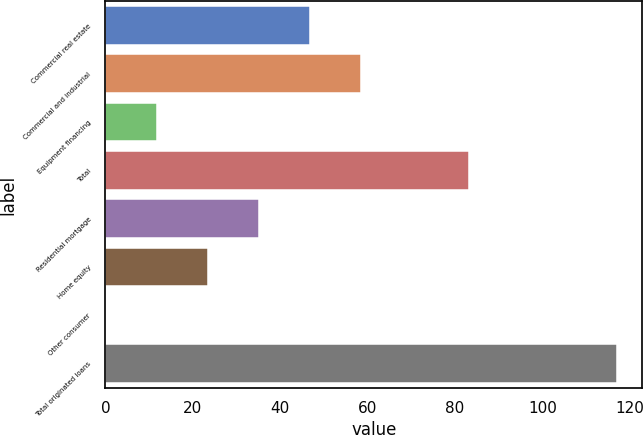Convert chart to OTSL. <chart><loc_0><loc_0><loc_500><loc_500><bar_chart><fcel>Commercial real estate<fcel>Commercial and industrial<fcel>Equipment financing<fcel>Total<fcel>Residential mortgage<fcel>Home equity<fcel>Other consumer<fcel>Total originated loans<nl><fcel>46.86<fcel>58.55<fcel>11.79<fcel>83.2<fcel>35.17<fcel>23.48<fcel>0.1<fcel>117<nl></chart> 